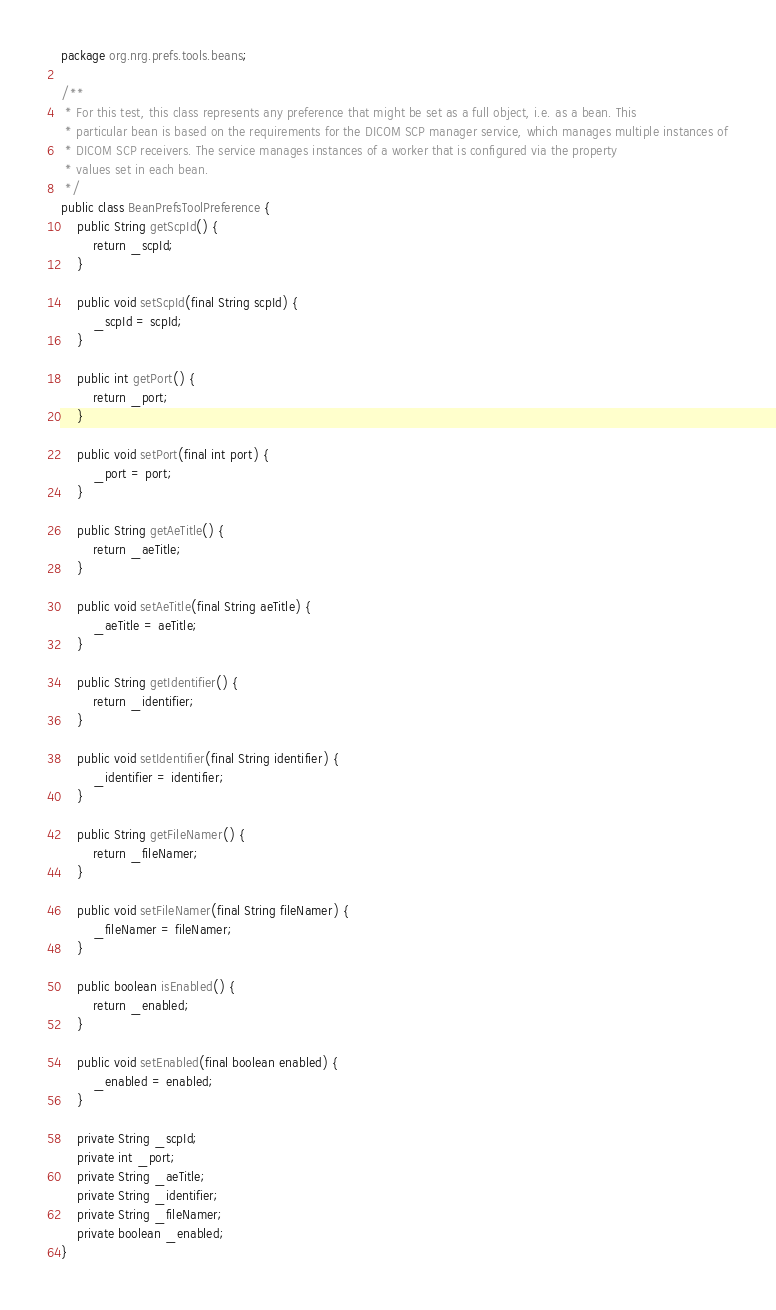<code> <loc_0><loc_0><loc_500><loc_500><_Java_>package org.nrg.prefs.tools.beans;

/**
 * For this test, this class represents any preference that might be set as a full object, i.e. as a bean. This
 * particular bean is based on the requirements for the DICOM SCP manager service, which manages multiple instances of
 * DICOM SCP receivers. The service manages instances of a worker that is configured via the property
 * values set in each bean.
 */
public class BeanPrefsToolPreference {
    public String getScpId() {
        return _scpId;
    }

    public void setScpId(final String scpId) {
        _scpId = scpId;
    }

    public int getPort() {
        return _port;
    }

    public void setPort(final int port) {
        _port = port;
    }

    public String getAeTitle() {
        return _aeTitle;
    }

    public void setAeTitle(final String aeTitle) {
        _aeTitle = aeTitle;
    }

    public String getIdentifier() {
        return _identifier;
    }

    public void setIdentifier(final String identifier) {
        _identifier = identifier;
    }

    public String getFileNamer() {
        return _fileNamer;
    }

    public void setFileNamer(final String fileNamer) {
        _fileNamer = fileNamer;
    }

    public boolean isEnabled() {
        return _enabled;
    }

    public void setEnabled(final boolean enabled) {
        _enabled = enabled;
    }

    private String _scpId;
    private int _port;
    private String _aeTitle;
    private String _identifier;
    private String _fileNamer;
    private boolean _enabled;
}
</code> 